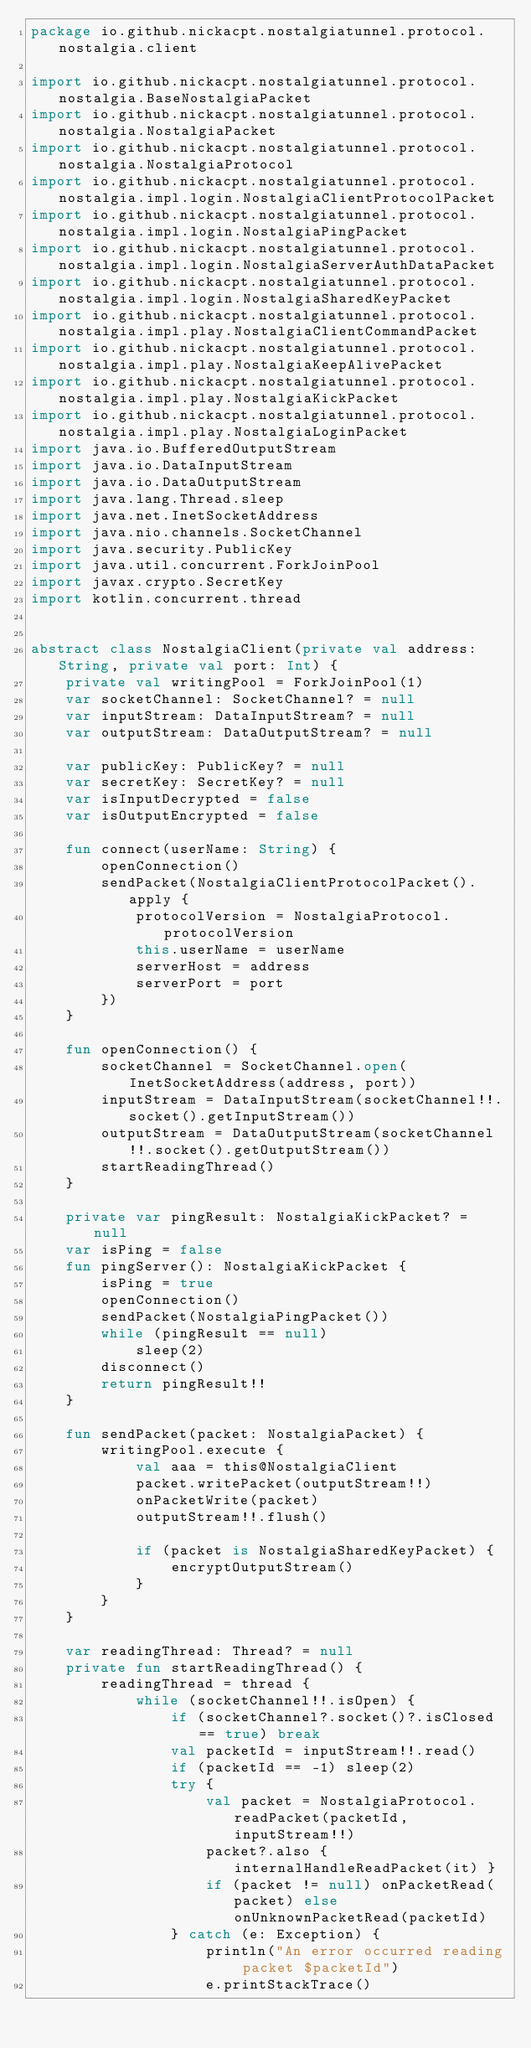Convert code to text. <code><loc_0><loc_0><loc_500><loc_500><_Kotlin_>package io.github.nickacpt.nostalgiatunnel.protocol.nostalgia.client

import io.github.nickacpt.nostalgiatunnel.protocol.nostalgia.BaseNostalgiaPacket
import io.github.nickacpt.nostalgiatunnel.protocol.nostalgia.NostalgiaPacket
import io.github.nickacpt.nostalgiatunnel.protocol.nostalgia.NostalgiaProtocol
import io.github.nickacpt.nostalgiatunnel.protocol.nostalgia.impl.login.NostalgiaClientProtocolPacket
import io.github.nickacpt.nostalgiatunnel.protocol.nostalgia.impl.login.NostalgiaPingPacket
import io.github.nickacpt.nostalgiatunnel.protocol.nostalgia.impl.login.NostalgiaServerAuthDataPacket
import io.github.nickacpt.nostalgiatunnel.protocol.nostalgia.impl.login.NostalgiaSharedKeyPacket
import io.github.nickacpt.nostalgiatunnel.protocol.nostalgia.impl.play.NostalgiaClientCommandPacket
import io.github.nickacpt.nostalgiatunnel.protocol.nostalgia.impl.play.NostalgiaKeepAlivePacket
import io.github.nickacpt.nostalgiatunnel.protocol.nostalgia.impl.play.NostalgiaKickPacket
import io.github.nickacpt.nostalgiatunnel.protocol.nostalgia.impl.play.NostalgiaLoginPacket
import java.io.BufferedOutputStream
import java.io.DataInputStream
import java.io.DataOutputStream
import java.lang.Thread.sleep
import java.net.InetSocketAddress
import java.nio.channels.SocketChannel
import java.security.PublicKey
import java.util.concurrent.ForkJoinPool
import javax.crypto.SecretKey
import kotlin.concurrent.thread


abstract class NostalgiaClient(private val address: String, private val port: Int) {
    private val writingPool = ForkJoinPool(1)
    var socketChannel: SocketChannel? = null
    var inputStream: DataInputStream? = null
    var outputStream: DataOutputStream? = null

    var publicKey: PublicKey? = null
    var secretKey: SecretKey? = null
    var isInputDecrypted = false
    var isOutputEncrypted = false

    fun connect(userName: String) {
        openConnection()
        sendPacket(NostalgiaClientProtocolPacket().apply {
            protocolVersion = NostalgiaProtocol.protocolVersion
            this.userName = userName
            serverHost = address
            serverPort = port
        })
    }

    fun openConnection() {
        socketChannel = SocketChannel.open(InetSocketAddress(address, port))
        inputStream = DataInputStream(socketChannel!!.socket().getInputStream())
        outputStream = DataOutputStream(socketChannel!!.socket().getOutputStream())
        startReadingThread()
    }

    private var pingResult: NostalgiaKickPacket? = null
    var isPing = false
    fun pingServer(): NostalgiaKickPacket {
        isPing = true
        openConnection()
        sendPacket(NostalgiaPingPacket())
        while (pingResult == null)
            sleep(2)
        disconnect()
        return pingResult!!
    }

    fun sendPacket(packet: NostalgiaPacket) {
        writingPool.execute {
            val aaa = this@NostalgiaClient
            packet.writePacket(outputStream!!)
            onPacketWrite(packet)
            outputStream!!.flush()

            if (packet is NostalgiaSharedKeyPacket) {
                encryptOutputStream()
            }
        }
    }

    var readingThread: Thread? = null
    private fun startReadingThread() {
        readingThread = thread {
            while (socketChannel!!.isOpen) {
                if (socketChannel?.socket()?.isClosed == true) break
                val packetId = inputStream!!.read()
                if (packetId == -1) sleep(2)
                try {
                    val packet = NostalgiaProtocol.readPacket(packetId, inputStream!!)
                    packet?.also { internalHandleReadPacket(it) }
                    if (packet != null) onPacketRead(packet) else onUnknownPacketRead(packetId)
                } catch (e: Exception) {
                    println("An error occurred reading packet $packetId")
                    e.printStackTrace()</code> 